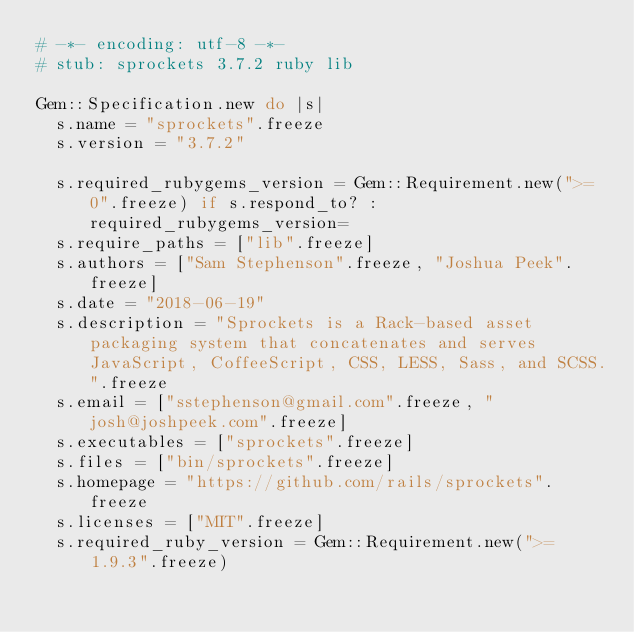Convert code to text. <code><loc_0><loc_0><loc_500><loc_500><_Ruby_># -*- encoding: utf-8 -*-
# stub: sprockets 3.7.2 ruby lib

Gem::Specification.new do |s|
  s.name = "sprockets".freeze
  s.version = "3.7.2"

  s.required_rubygems_version = Gem::Requirement.new(">= 0".freeze) if s.respond_to? :required_rubygems_version=
  s.require_paths = ["lib".freeze]
  s.authors = ["Sam Stephenson".freeze, "Joshua Peek".freeze]
  s.date = "2018-06-19"
  s.description = "Sprockets is a Rack-based asset packaging system that concatenates and serves JavaScript, CoffeeScript, CSS, LESS, Sass, and SCSS.".freeze
  s.email = ["sstephenson@gmail.com".freeze, "josh@joshpeek.com".freeze]
  s.executables = ["sprockets".freeze]
  s.files = ["bin/sprockets".freeze]
  s.homepage = "https://github.com/rails/sprockets".freeze
  s.licenses = ["MIT".freeze]
  s.required_ruby_version = Gem::Requirement.new(">= 1.9.3".freeze)</code> 